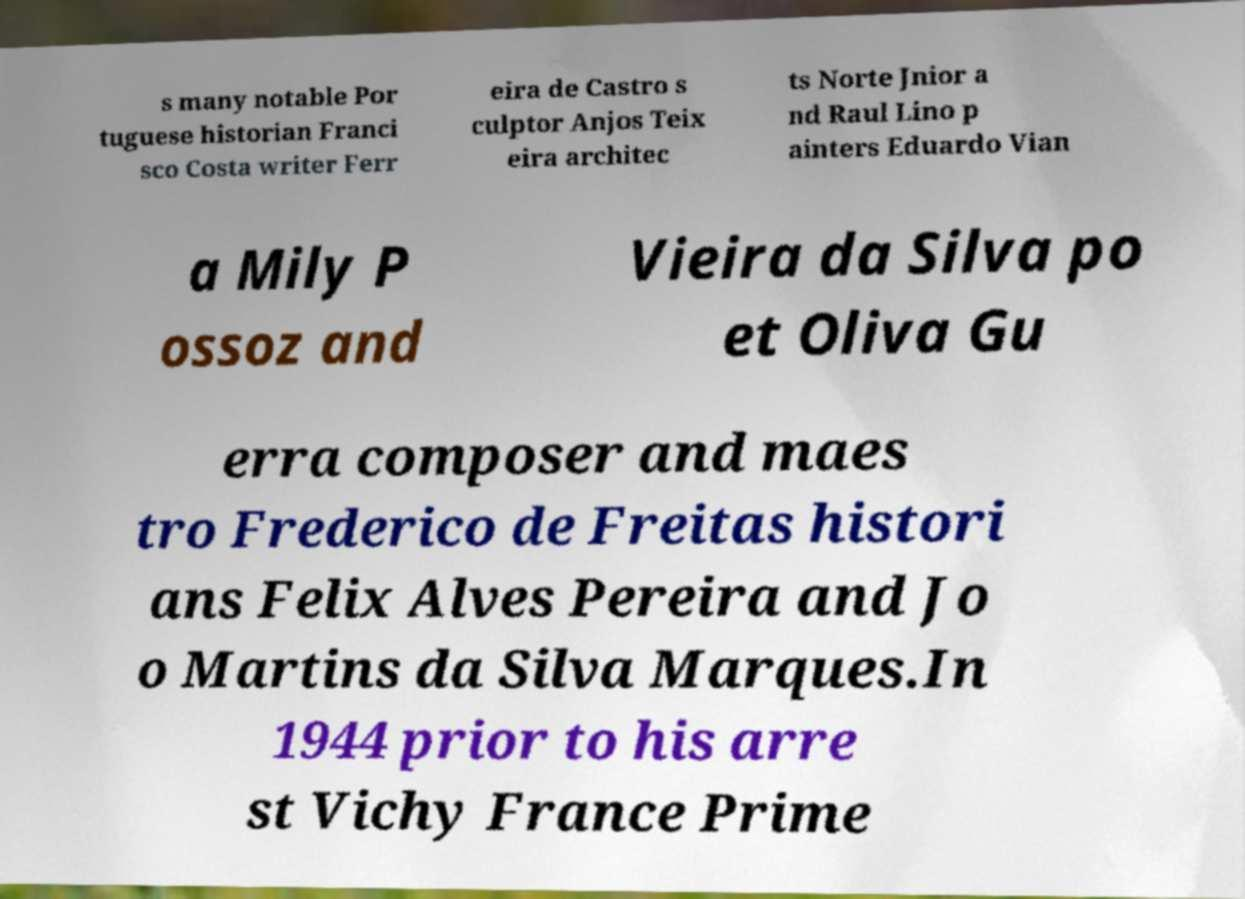Could you assist in decoding the text presented in this image and type it out clearly? s many notable Por tuguese historian Franci sco Costa writer Ferr eira de Castro s culptor Anjos Teix eira architec ts Norte Jnior a nd Raul Lino p ainters Eduardo Vian a Mily P ossoz and Vieira da Silva po et Oliva Gu erra composer and maes tro Frederico de Freitas histori ans Felix Alves Pereira and Jo o Martins da Silva Marques.In 1944 prior to his arre st Vichy France Prime 